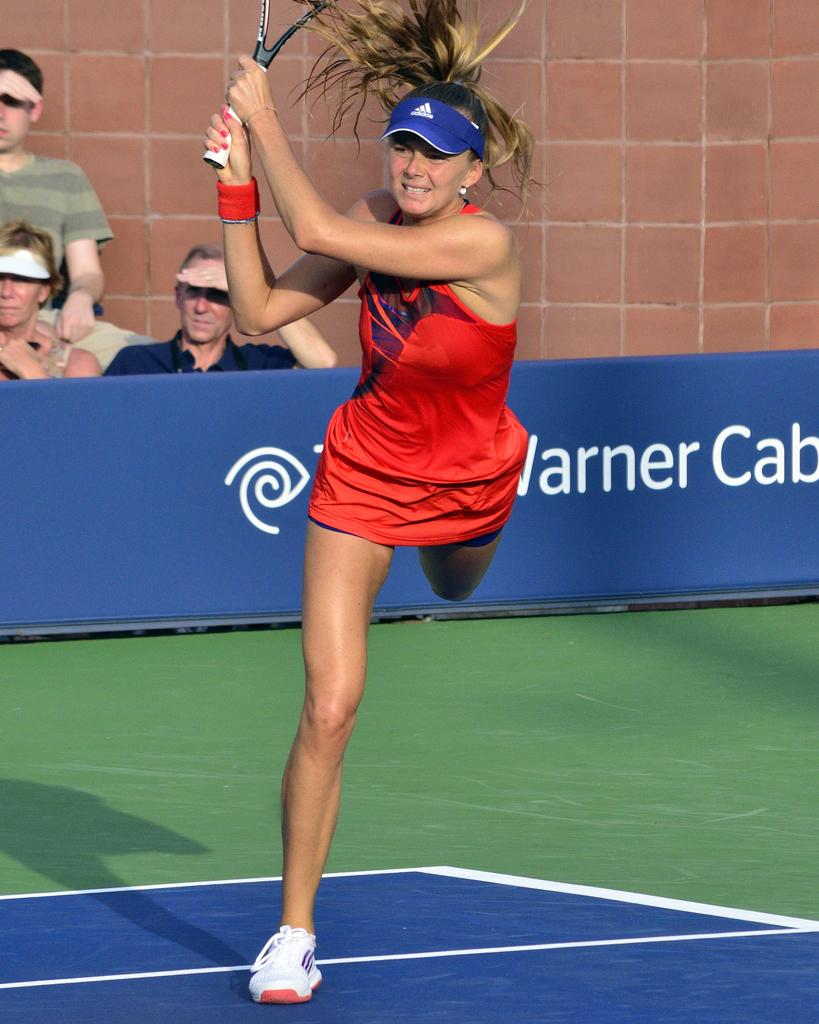What is the woman in the image doing? The woman is playing on the ground. Can you describe the background of the image? There are three persons in the background. What is a prominent feature in the image? There is a wall in the image. Is there any advertising or signage in the image? Yes, there is a hoarding in the image. What type of glue is being used by the woman in the image? There is no glue present in the image; the woman is playing on the ground. What is the value of the stamp on the hoarding in the image? There is no stamp present on the hoarding in the image. 